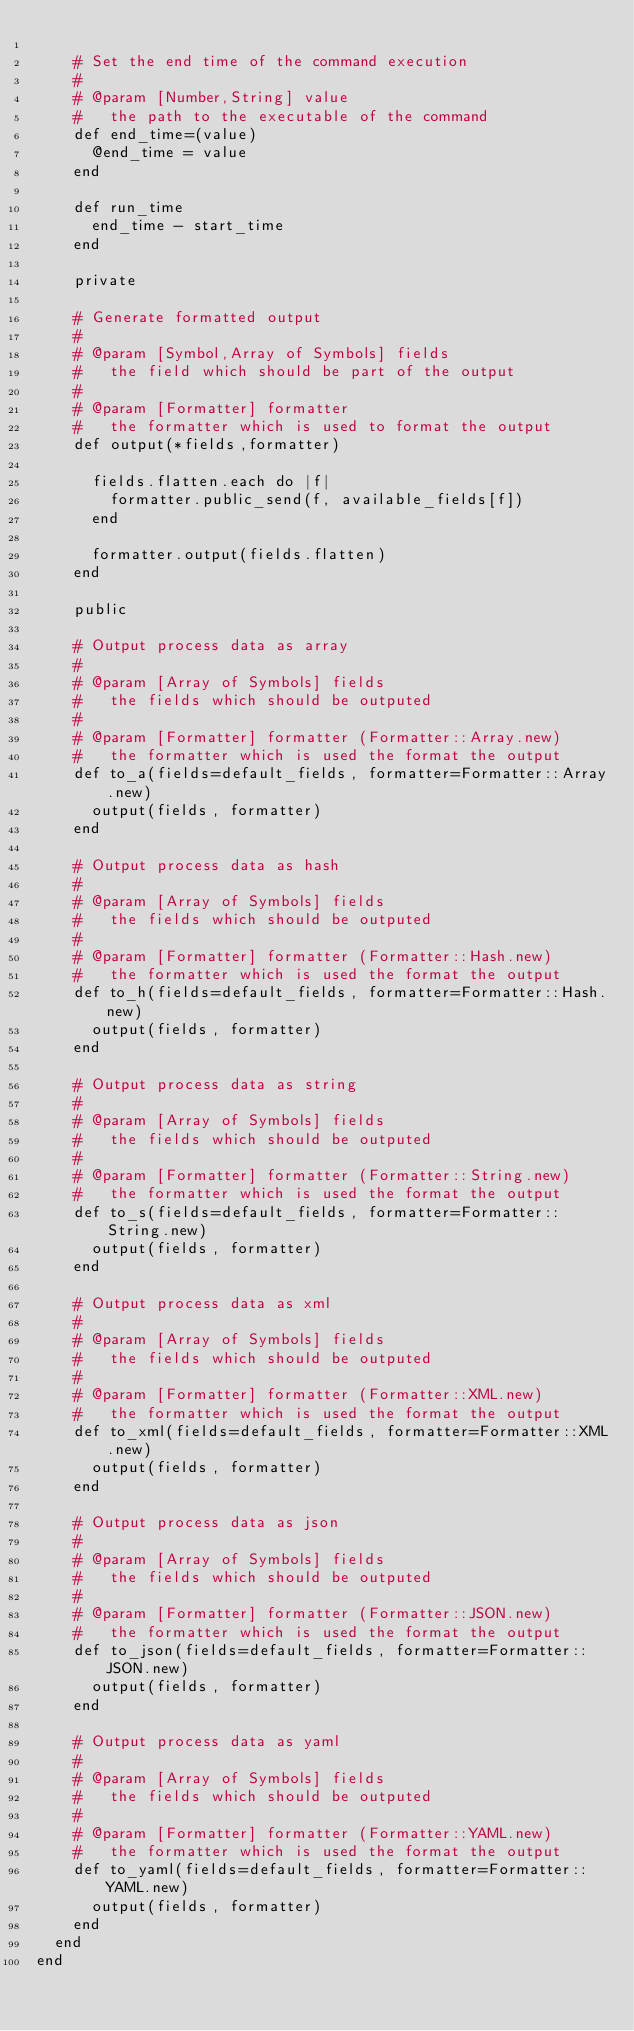<code> <loc_0><loc_0><loc_500><loc_500><_Ruby_>
    # Set the end time of the command execution
    #
    # @param [Number,String] value
    #   the path to the executable of the command 
    def end_time=(value)
      @end_time = value
    end

    def run_time
      end_time - start_time
    end

    private 

    # Generate formatted output
    #
    # @param [Symbol,Array of Symbols] fields
    #   the field which should be part of the output
    #
    # @param [Formatter] formatter
    #   the formatter which is used to format the output
    def output(*fields,formatter)

      fields.flatten.each do |f|
        formatter.public_send(f, available_fields[f])
      end

      formatter.output(fields.flatten)
    end

    public 

    # Output process data as array
    #
    # @param [Array of Symbols] fields
    #   the fields which should be outputed
    #
    # @param [Formatter] formatter (Formatter::Array.new)
    #   the formatter which is used the format the output
    def to_a(fields=default_fields, formatter=Formatter::Array.new)
      output(fields, formatter)
    end

    # Output process data as hash
    #
    # @param [Array of Symbols] fields
    #   the fields which should be outputed
    #
    # @param [Formatter] formatter (Formatter::Hash.new)
    #   the formatter which is used the format the output
    def to_h(fields=default_fields, formatter=Formatter::Hash.new)
      output(fields, formatter)
    end

    # Output process data as string
    #
    # @param [Array of Symbols] fields
    #   the fields which should be outputed
    #
    # @param [Formatter] formatter (Formatter::String.new)
    #   the formatter which is used the format the output
    def to_s(fields=default_fields, formatter=Formatter::String.new)
      output(fields, formatter)
    end

    # Output process data as xml
    #
    # @param [Array of Symbols] fields
    #   the fields which should be outputed
    #
    # @param [Formatter] formatter (Formatter::XML.new)
    #   the formatter which is used the format the output
    def to_xml(fields=default_fields, formatter=Formatter::XML.new)
      output(fields, formatter)
    end

    # Output process data as json
    #
    # @param [Array of Symbols] fields
    #   the fields which should be outputed
    #
    # @param [Formatter] formatter (Formatter::JSON.new)
    #   the formatter which is used the format the output
    def to_json(fields=default_fields, formatter=Formatter::JSON.new)
      output(fields, formatter)
    end

    # Output process data as yaml
    #
    # @param [Array of Symbols] fields
    #   the fields which should be outputed
    #
    # @param [Formatter] formatter (Formatter::YAML.new)
    #   the formatter which is used the format the output
    def to_yaml(fields=default_fields, formatter=Formatter::YAML.new)
      output(fields, formatter)
    end
  end
end

</code> 